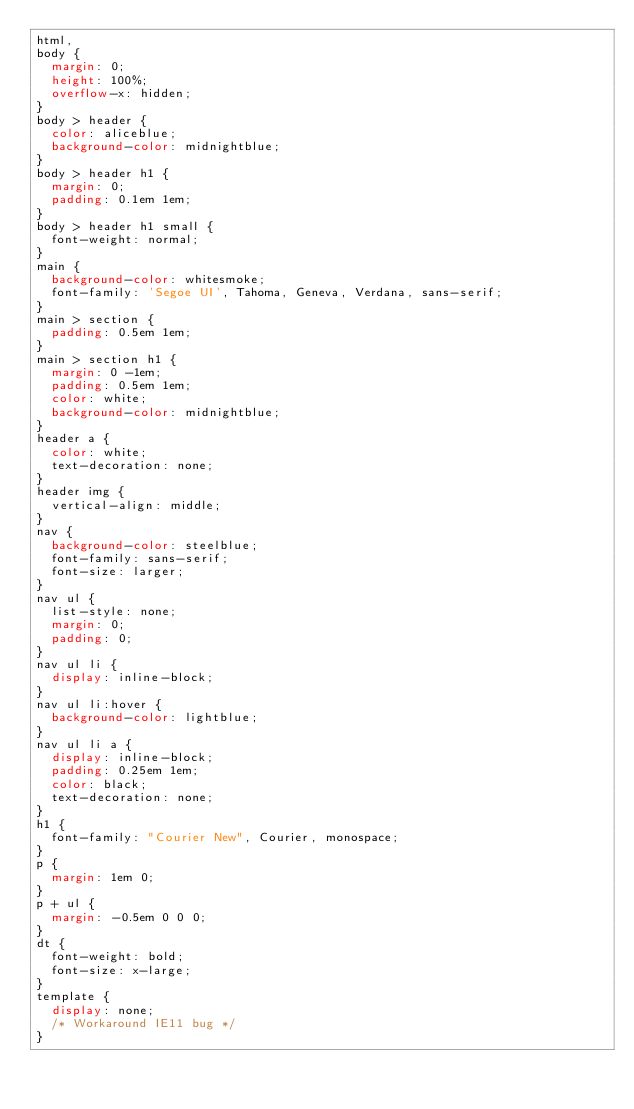Convert code to text. <code><loc_0><loc_0><loc_500><loc_500><_CSS_>html,
body {
  margin: 0;
  height: 100%;
  overflow-x: hidden;
}
body > header {
  color: aliceblue;
  background-color: midnightblue;
}
body > header h1 {
  margin: 0;
  padding: 0.1em 1em;
}
body > header h1 small {
  font-weight: normal;
}
main {
  background-color: whitesmoke;
  font-family: 'Segoe UI', Tahoma, Geneva, Verdana, sans-serif;
}
main > section {
  padding: 0.5em 1em;
}
main > section h1 {
  margin: 0 -1em;
  padding: 0.5em 1em;
  color: white;
  background-color: midnightblue;
}
header a {
  color: white;
  text-decoration: none;
}
header img {
  vertical-align: middle;
}
nav {
  background-color: steelblue;
  font-family: sans-serif;
  font-size: larger;
}
nav ul {
  list-style: none;
  margin: 0;
  padding: 0;
}
nav ul li {
  display: inline-block;
}
nav ul li:hover {
  background-color: lightblue;
}
nav ul li a {
  display: inline-block;
  padding: 0.25em 1em;
  color: black;
  text-decoration: none;
}
h1 {
  font-family: "Courier New", Courier, monospace;
}
p {
  margin: 1em 0;
}
p + ul {
  margin: -0.5em 0 0 0;
}
dt {
  font-weight: bold;
  font-size: x-large;
}
template {
  display: none;
  /* Workaround IE11 bug */
}
</code> 